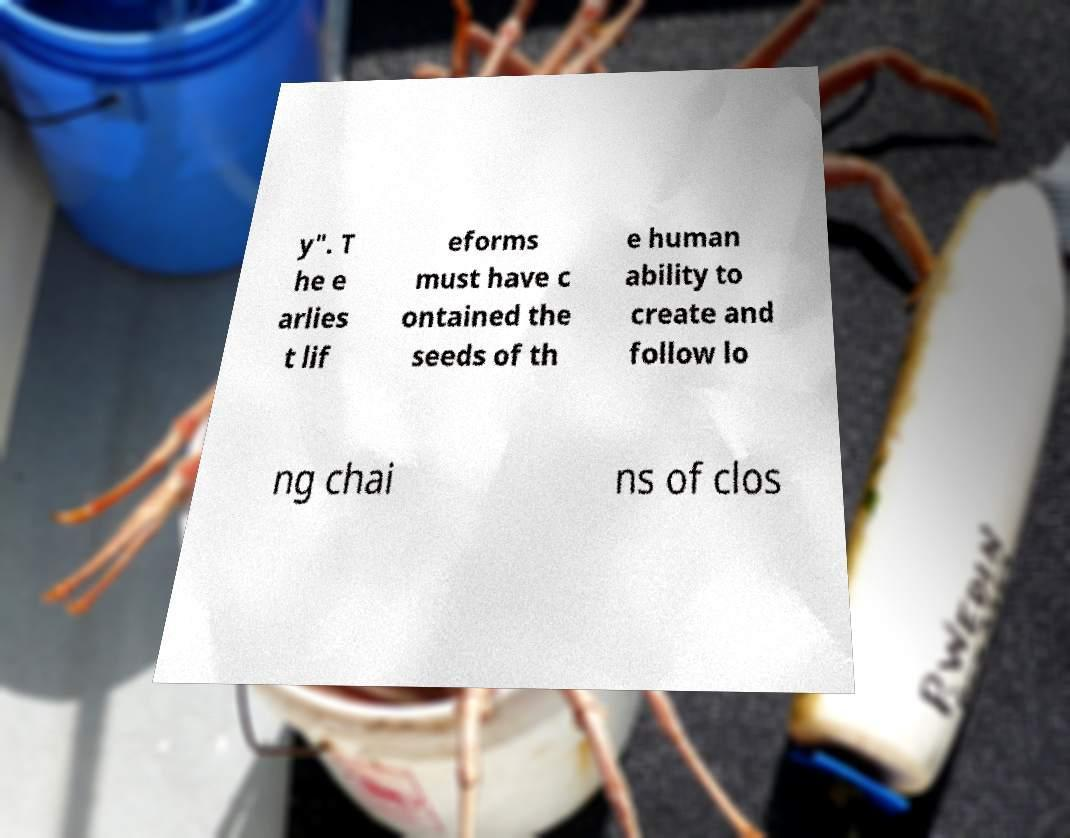Can you read and provide the text displayed in the image?This photo seems to have some interesting text. Can you extract and type it out for me? y". T he e arlies t lif eforms must have c ontained the seeds of th e human ability to create and follow lo ng chai ns of clos 